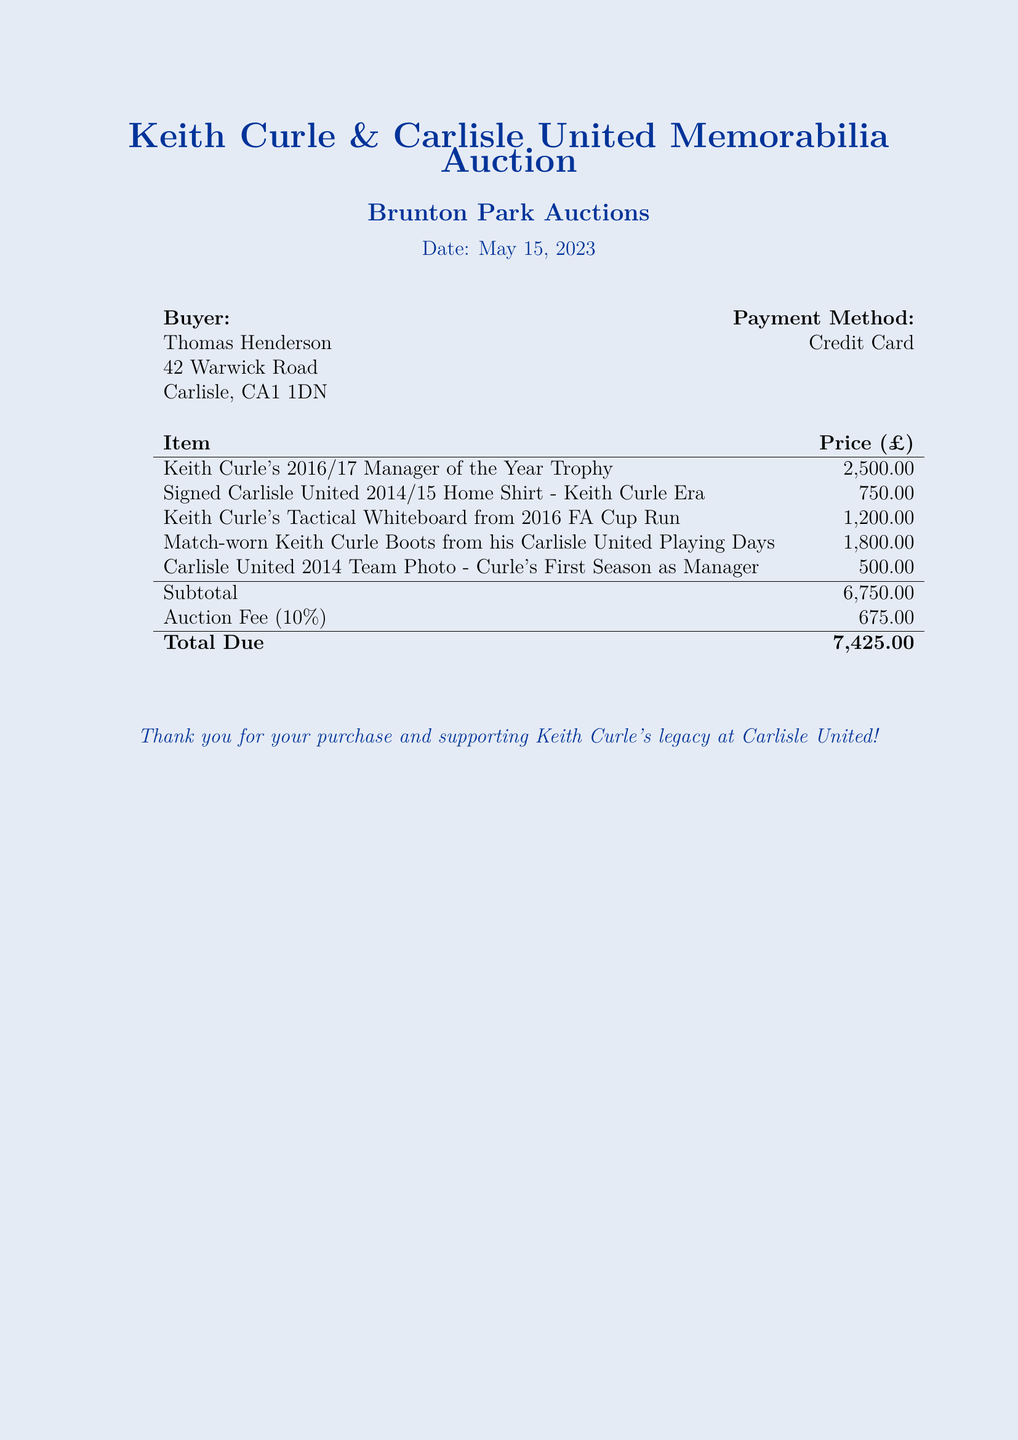What is the date of the auction? The auction date is prominently listed in the document.
Answer: May 15, 2023 Who is the buyer? The buyer's name is displayed at the top of the document.
Answer: Thomas Henderson What is the total amount due? The total due is calculated at the bottom of the bill.
Answer: 7,425.00 How much was the auction fee? The auction fee is specified as a percentage of the subtotal.
Answer: 675.00 What is the price of Keith Curle's 2016/17 Manager of the Year Trophy? The price is listed in the itemized section alongside each item.
Answer: 2,500.00 How many items were purchased in total? Counting the listed items in the document yields the total.
Answer: 5 What is the price of the signed Carlisle United 2014/15 Home Shirt? The price is explicitly noted in the document next to the item.
Answer: 750.00 What is the subtotal before the auction fee? The subtotal is calculated from the combined prices of all items.
Answer: 6,750.00 What memorabilia item relates to Keith Curle's tactical preparation? The document describes an item related to Curle's tactical planning.
Answer: Keith Curle's Tactical Whiteboard from 2016 FA Cup Run 